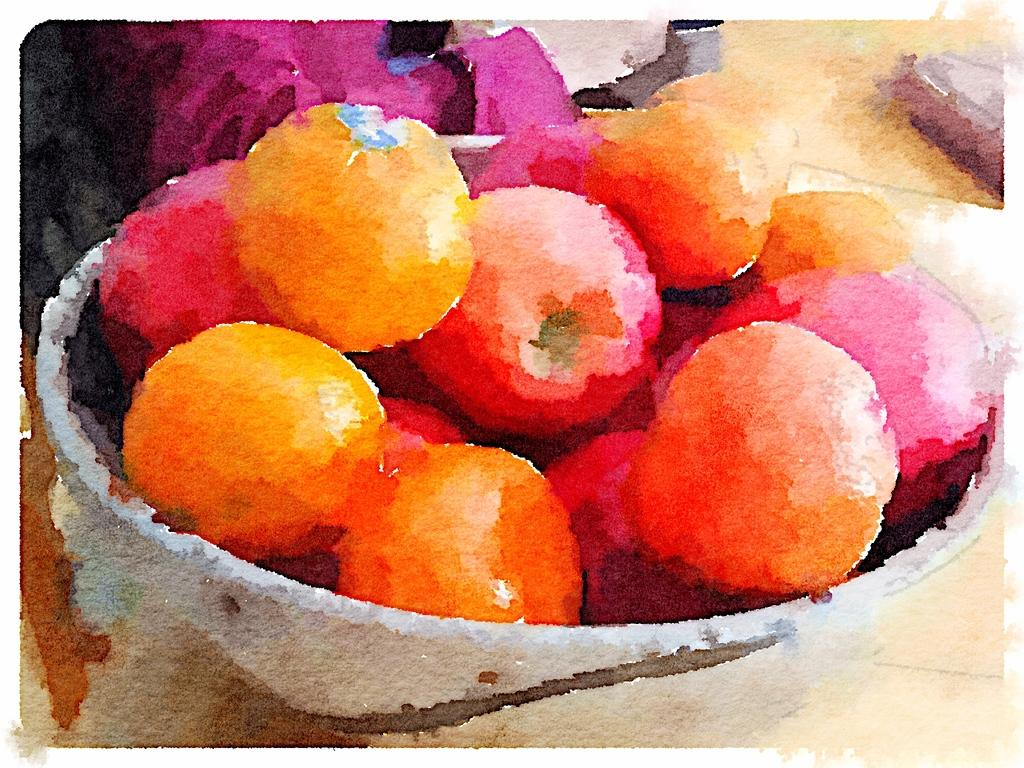What is the style of the image? The image resembles a painting. What can be seen in the painting? There are fruits in a bowl in the image. What type of plough is being used in the painting? There is no plough present in the painting; it features a bowl of fruits. What lesson is being taught in the painting? The painting does not depict a teaching scenario; it simply shows a bowl of fruits. 